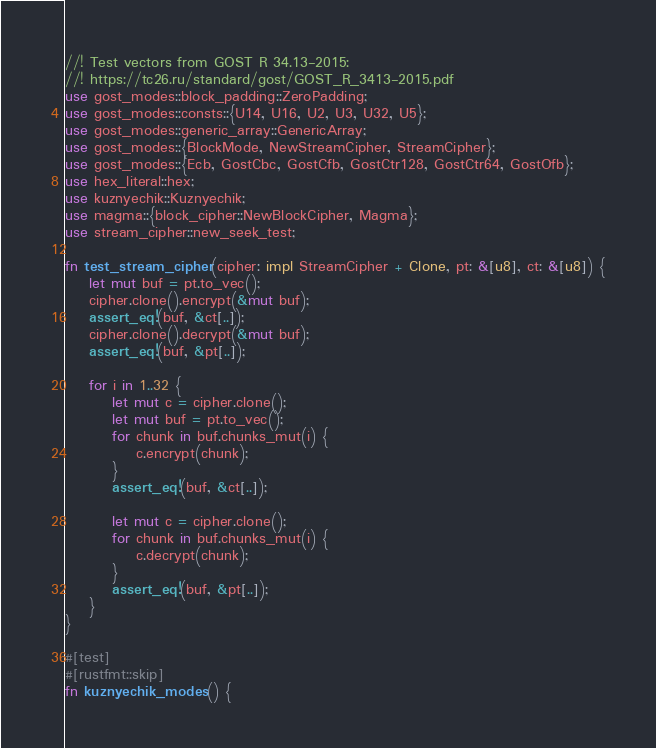<code> <loc_0><loc_0><loc_500><loc_500><_Rust_>//! Test vectors from GOST R 34.13-2015:
//! https://tc26.ru/standard/gost/GOST_R_3413-2015.pdf
use gost_modes::block_padding::ZeroPadding;
use gost_modes::consts::{U14, U16, U2, U3, U32, U5};
use gost_modes::generic_array::GenericArray;
use gost_modes::{BlockMode, NewStreamCipher, StreamCipher};
use gost_modes::{Ecb, GostCbc, GostCfb, GostCtr128, GostCtr64, GostOfb};
use hex_literal::hex;
use kuznyechik::Kuznyechik;
use magma::{block_cipher::NewBlockCipher, Magma};
use stream_cipher::new_seek_test;

fn test_stream_cipher(cipher: impl StreamCipher + Clone, pt: &[u8], ct: &[u8]) {
    let mut buf = pt.to_vec();
    cipher.clone().encrypt(&mut buf);
    assert_eq!(buf, &ct[..]);
    cipher.clone().decrypt(&mut buf);
    assert_eq!(buf, &pt[..]);

    for i in 1..32 {
        let mut c = cipher.clone();
        let mut buf = pt.to_vec();
        for chunk in buf.chunks_mut(i) {
            c.encrypt(chunk);
        }
        assert_eq!(buf, &ct[..]);

        let mut c = cipher.clone();
        for chunk in buf.chunks_mut(i) {
            c.decrypt(chunk);
        }
        assert_eq!(buf, &pt[..]);
    }
}

#[test]
#[rustfmt::skip]
fn kuznyechik_modes() {</code> 